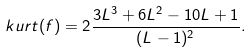<formula> <loc_0><loc_0><loc_500><loc_500>k u r t ( f ) = 2 \frac { 3 L ^ { 3 } + 6 L ^ { 2 } - 1 0 L + 1 } { ( L - 1 ) ^ { 2 } } .</formula> 